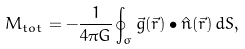<formula> <loc_0><loc_0><loc_500><loc_500>M _ { t o t } = - \frac { 1 } { 4 \pi G } \oint _ { \sigma } \vec { g } ( \vec { r } ) \bullet \hat { n } ( \vec { r } ) \, d S ,</formula> 